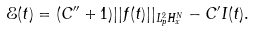Convert formula to latex. <formula><loc_0><loc_0><loc_500><loc_500>\mathcal { E } ( t ) = ( C ^ { \prime \prime } + 1 ) | | f ( t ) | | _ { L ^ { 2 } _ { p } H ^ { N } _ { x } } - C ^ { \prime } I ( t ) .</formula> 